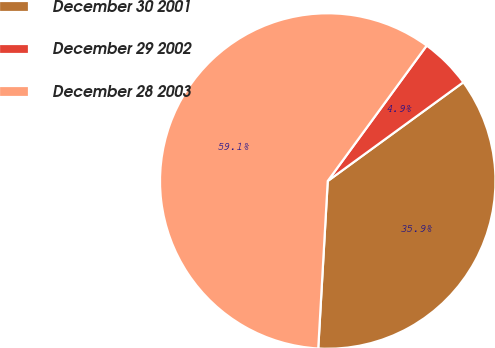Convert chart to OTSL. <chart><loc_0><loc_0><loc_500><loc_500><pie_chart><fcel>December 30 2001<fcel>December 29 2002<fcel>December 28 2003<nl><fcel>35.92%<fcel>4.94%<fcel>59.14%<nl></chart> 